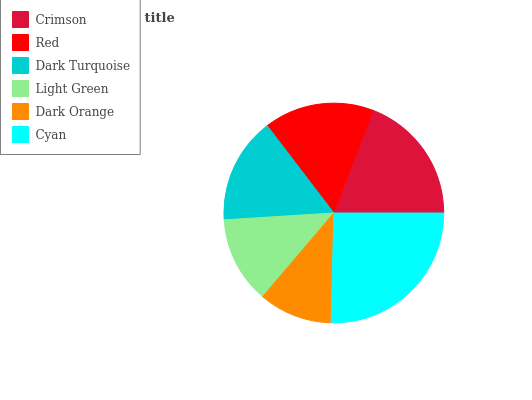Is Dark Orange the minimum?
Answer yes or no. Yes. Is Cyan the maximum?
Answer yes or no. Yes. Is Red the minimum?
Answer yes or no. No. Is Red the maximum?
Answer yes or no. No. Is Crimson greater than Red?
Answer yes or no. Yes. Is Red less than Crimson?
Answer yes or no. Yes. Is Red greater than Crimson?
Answer yes or no. No. Is Crimson less than Red?
Answer yes or no. No. Is Red the high median?
Answer yes or no. Yes. Is Dark Turquoise the low median?
Answer yes or no. Yes. Is Cyan the high median?
Answer yes or no. No. Is Red the low median?
Answer yes or no. No. 